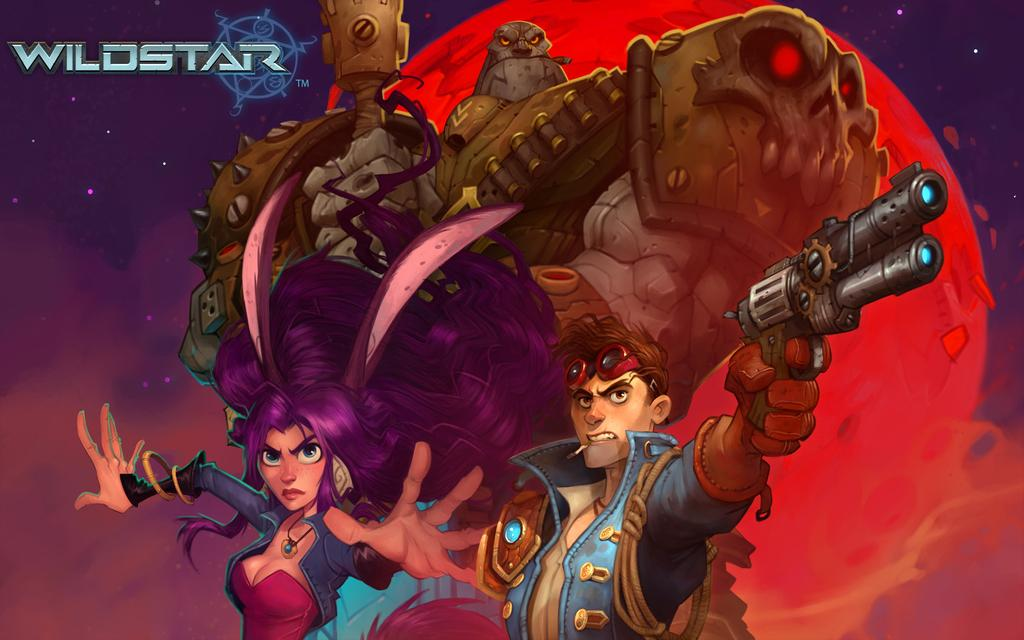How many people are in the image? There are three persons in the image. What is one of the persons holding? One of the persons is holding a rifle. What else can be seen in the image besides the people? There is a symbol and letters in the image. What type of unit is being measured in the image? There is no unit being measured in the image; it features three persons, a rifle, a symbol, and letters. What is the source of the field in the image? There is no field present in the image. 